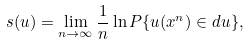Convert formula to latex. <formula><loc_0><loc_0><loc_500><loc_500>s ( u ) = \lim _ { n \rightarrow \infty } \frac { 1 } { n } \ln P \{ u ( x ^ { n } ) \in d u \} ,</formula> 